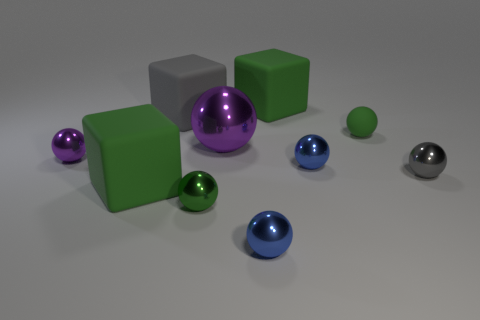Is there anything else of the same color as the small rubber ball?
Give a very brief answer. Yes. What is the material of the big purple thing that is the same shape as the small rubber thing?
Provide a succinct answer. Metal. How many other things are there of the same size as the green metal ball?
Offer a terse response. 5. The shiny sphere that is the same color as the large metal thing is what size?
Offer a very short reply. Small. There is a gray thing that is left of the tiny green metal thing; does it have the same shape as the tiny purple metallic object?
Your response must be concise. No. How many other things are there of the same shape as the green shiny thing?
Provide a short and direct response. 6. There is a matte object in front of the small green matte sphere; what shape is it?
Your answer should be very brief. Cube. Are there any things made of the same material as the tiny gray sphere?
Your answer should be compact. Yes. There is a large object behind the big gray rubber block; does it have the same color as the matte ball?
Your answer should be very brief. Yes. What size is the gray cube?
Make the answer very short. Large. 